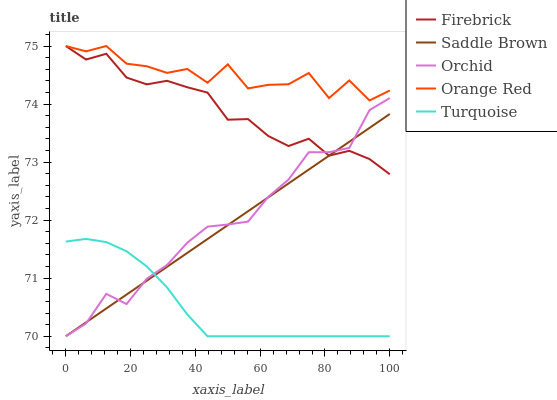Does Turquoise have the minimum area under the curve?
Answer yes or no. Yes. Does Orange Red have the maximum area under the curve?
Answer yes or no. Yes. Does Saddle Brown have the minimum area under the curve?
Answer yes or no. No. Does Saddle Brown have the maximum area under the curve?
Answer yes or no. No. Is Saddle Brown the smoothest?
Answer yes or no. Yes. Is Orange Red the roughest?
Answer yes or no. Yes. Is Turquoise the smoothest?
Answer yes or no. No. Is Turquoise the roughest?
Answer yes or no. No. Does Turquoise have the lowest value?
Answer yes or no. Yes. Does Orange Red have the lowest value?
Answer yes or no. No. Does Orange Red have the highest value?
Answer yes or no. Yes. Does Saddle Brown have the highest value?
Answer yes or no. No. Is Saddle Brown less than Orange Red?
Answer yes or no. Yes. Is Orange Red greater than Saddle Brown?
Answer yes or no. Yes. Does Firebrick intersect Saddle Brown?
Answer yes or no. Yes. Is Firebrick less than Saddle Brown?
Answer yes or no. No. Is Firebrick greater than Saddle Brown?
Answer yes or no. No. Does Saddle Brown intersect Orange Red?
Answer yes or no. No. 